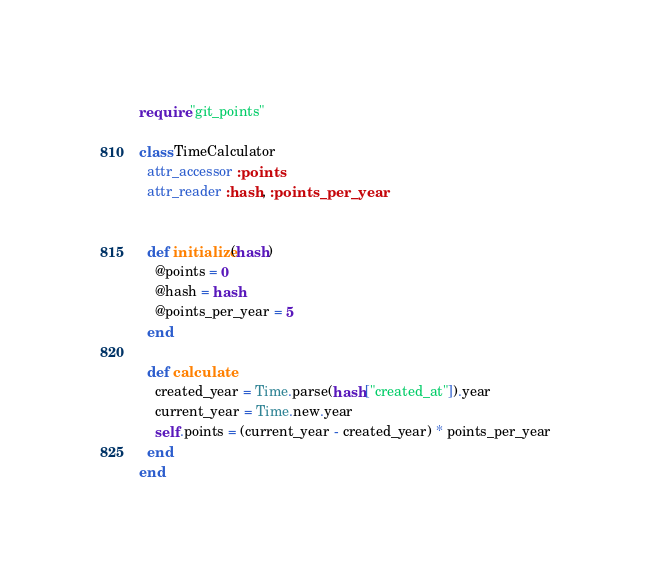Convert code to text. <code><loc_0><loc_0><loc_500><loc_500><_Ruby_>require "git_points"

class TimeCalculator
  attr_accessor :points
  attr_reader :hash, :points_per_year


  def initialize(hash)
    @points = 0
    @hash = hash
    @points_per_year = 5
  end

  def calculate
    created_year = Time.parse(hash["created_at"]).year
    current_year = Time.new.year
    self.points = (current_year - created_year) * points_per_year
  end
end
</code> 